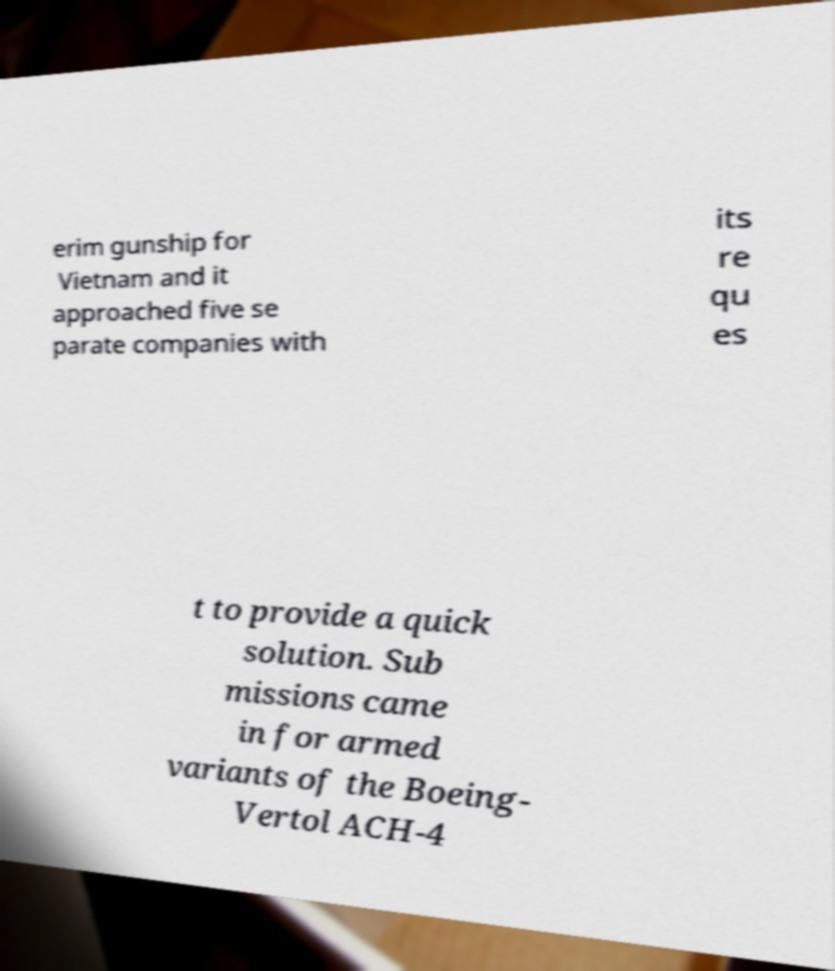Could you assist in decoding the text presented in this image and type it out clearly? erim gunship for Vietnam and it approached five se parate companies with its re qu es t to provide a quick solution. Sub missions came in for armed variants of the Boeing- Vertol ACH-4 